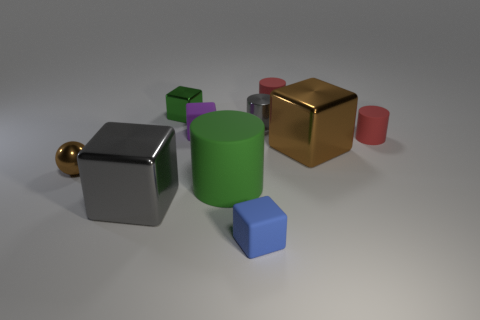Subtract 2 cubes. How many cubes are left? 3 Subtract all green cubes. How many cubes are left? 4 Subtract all cyan cubes. Subtract all cyan balls. How many cubes are left? 5 Subtract all spheres. How many objects are left? 9 Add 9 matte balls. How many matte balls exist? 9 Subtract 0 brown cylinders. How many objects are left? 10 Subtract all small gray matte cubes. Subtract all rubber cylinders. How many objects are left? 7 Add 4 large gray metal objects. How many large gray metal objects are left? 5 